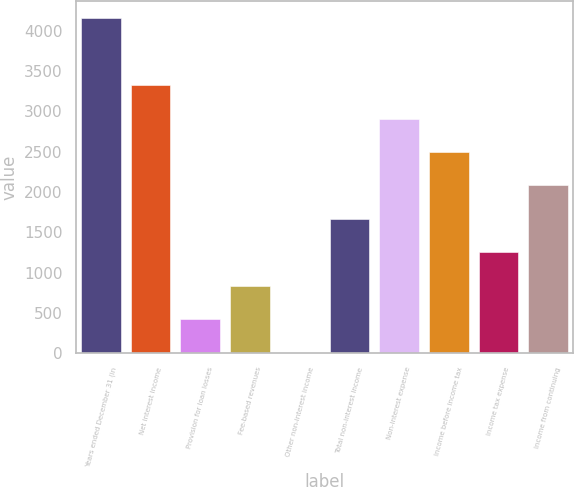Convert chart to OTSL. <chart><loc_0><loc_0><loc_500><loc_500><bar_chart><fcel>Years ended December 31 (in<fcel>Net interest income<fcel>Provision for loan losses<fcel>Fee-based revenues<fcel>Other non-interest income<fcel>Total non-interest income<fcel>Non-interest expense<fcel>Income before income tax<fcel>Income tax expense<fcel>Income from continuing<nl><fcel>4155<fcel>3325<fcel>420<fcel>835<fcel>5<fcel>1665<fcel>2910<fcel>2495<fcel>1250<fcel>2080<nl></chart> 